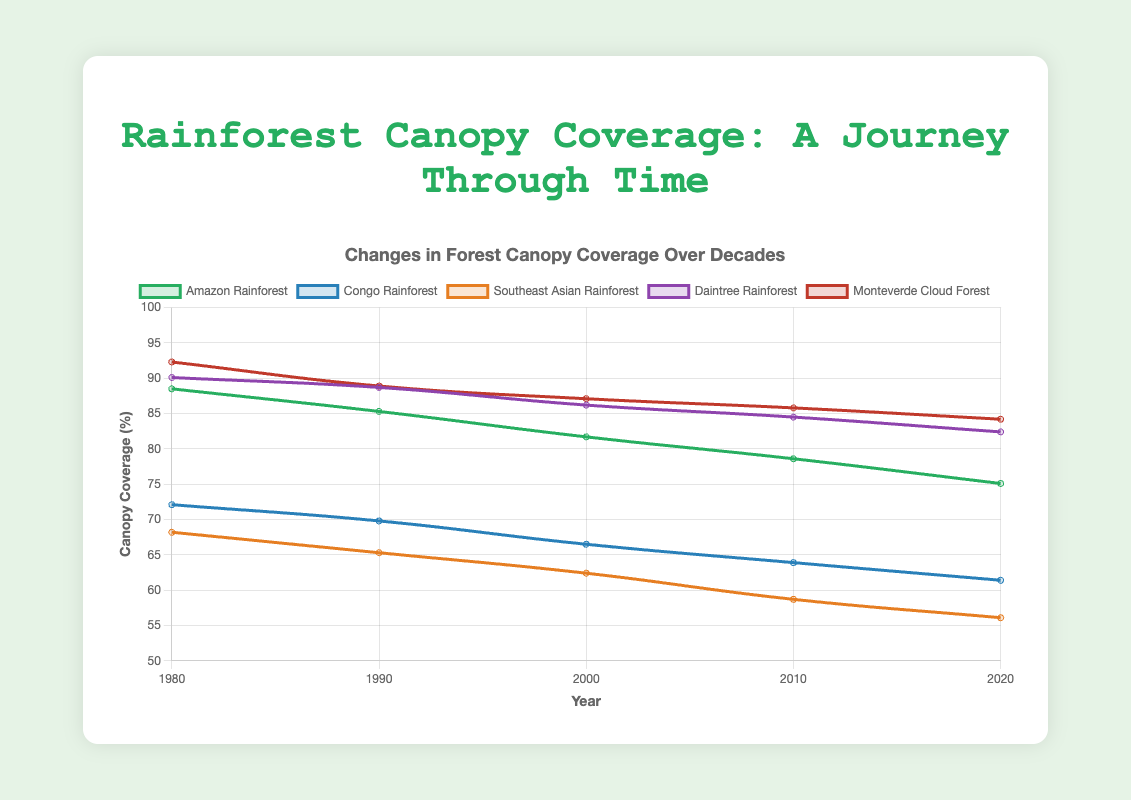Which rainforest region experienced the greatest decrease in canopy coverage from 1980 to 2020? To determine this, calculate the difference in canopy coverage for each region between 1980 and 2020, and find the region with the largest difference. The differences are: Amazon Rainforest (88.5 - 75.1 = 13.4), Congo Rainforest (72.1 - 61.4 = 10.7), Southeast Asian Rainforest (68.2 - 56.1 = 12.1), Daintree Rainforest (90.1 - 82.4 = 7.7), Monteverde Cloud Forest (92.3 - 84.2 = 8.1). The Amazon Rainforest has the largest decrease.
Answer: Amazon Rainforest What was the average canopy coverage for the Daintree Rainforest across all decades shown? Calculate the sum of the canopy coverages for the Daintree Rainforest (90.1 + 88.7 + 86.2 + 84.5 + 82.4 = 432.9) and then divide by the number of decades (5). The average is 432.9 / 5 = 86.58.
Answer: 86.58 Which rainforest region had the highest canopy coverage in 2010? Check the canopy coverage values for all regions in the year 2010: Amazon Rainforest (78.6), Congo Rainforest (63.9), Southeast Asian Rainforest (58.7), Daintree Rainforest (84.5), Monteverde Cloud Forest (85.8). The Monteverde Cloud Forest had the highest canopy coverage in 2010.
Answer: Monteverde Cloud Forest By how much did the canopy coverage of the Congo Rainforest decrease from 1990 to 2000? Subtract the 2000 value from the 1990 value for the Congo Rainforest: 69.8 - 66.5 = 3.3.
Answer: 3.3 Did any rainforest region have an increase in canopy coverage between any two decades? If so, which one and between which decades? Review the data to see if any region's canopy coverage increased between any two decades. After checking, no region showed an increase between any recorded decades.
Answer: No Which rainforest had the lowest starting canopy coverage in 1980? Compare the canopy coverage values in 1980 for all regions: Amazon (88.5), Congo (72.1), Southeast Asian (68.2), Daintree (90.1), Monteverde Cloud Forest (92.3). The Southeast Asian Rainforest had the lowest starting canopy coverage.
Answer: Southeast Asian Rainforest What is the average decrease in canopy coverage per decade for the Amazon Rainforest? Calculate the difference in coverage for each decade for the Amazon Rainforest (88.5 - 85.3 = 3.2, 85.3 - 81.7 = 3.6, 81.7 - 78.6 = 3.1, 78.6 - 75.1 = 3.5) and then find the average of these differences: (3.2 + 3.6 + 3.1 + 3.5) / 4 = 3.35.
Answer: 3.35 